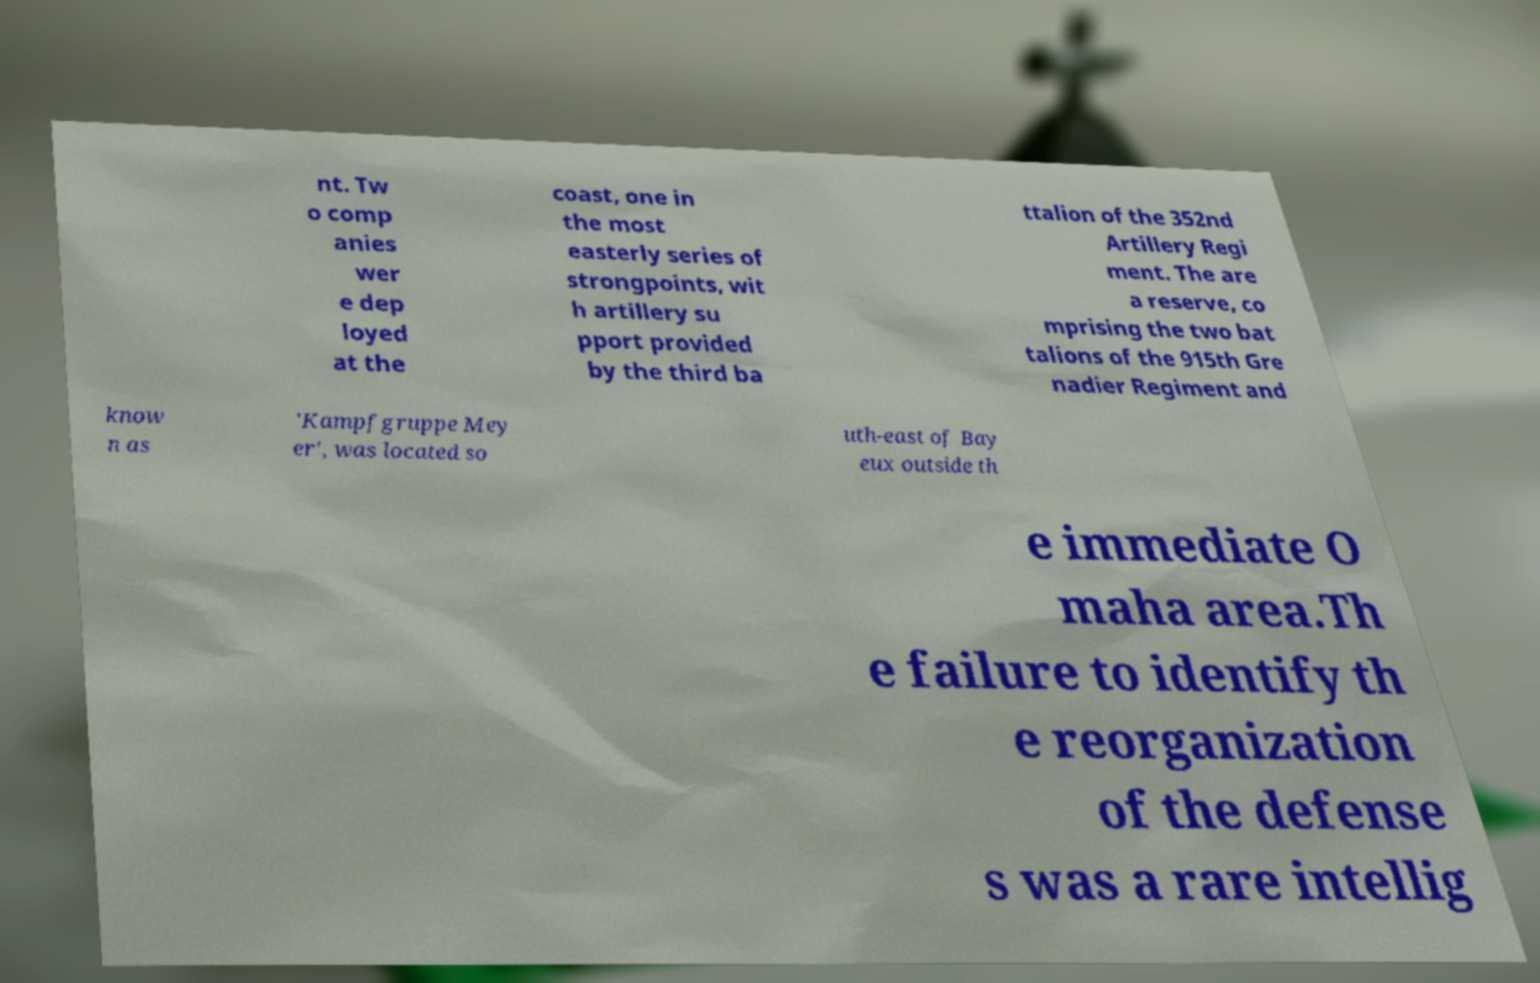Please identify and transcribe the text found in this image. nt. Tw o comp anies wer e dep loyed at the coast, one in the most easterly series of strongpoints, wit h artillery su pport provided by the third ba ttalion of the 352nd Artillery Regi ment. The are a reserve, co mprising the two bat talions of the 915th Gre nadier Regiment and know n as 'Kampfgruppe Mey er', was located so uth-east of Bay eux outside th e immediate O maha area.Th e failure to identify th e reorganization of the defense s was a rare intellig 